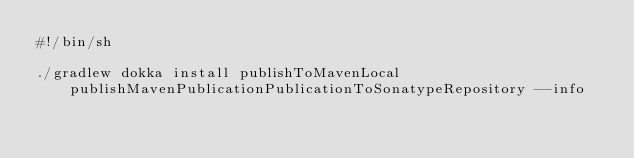<code> <loc_0><loc_0><loc_500><loc_500><_Bash_>#!/bin/sh

./gradlew dokka install publishToMavenLocal publishMavenPublicationPublicationToSonatypeRepository --info</code> 